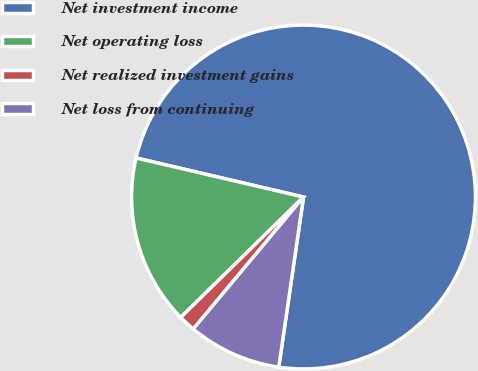Convert chart. <chart><loc_0><loc_0><loc_500><loc_500><pie_chart><fcel>Net investment income<fcel>Net operating loss<fcel>Net realized investment gains<fcel>Net loss from continuing<nl><fcel>73.65%<fcel>15.99%<fcel>1.58%<fcel>8.78%<nl></chart> 